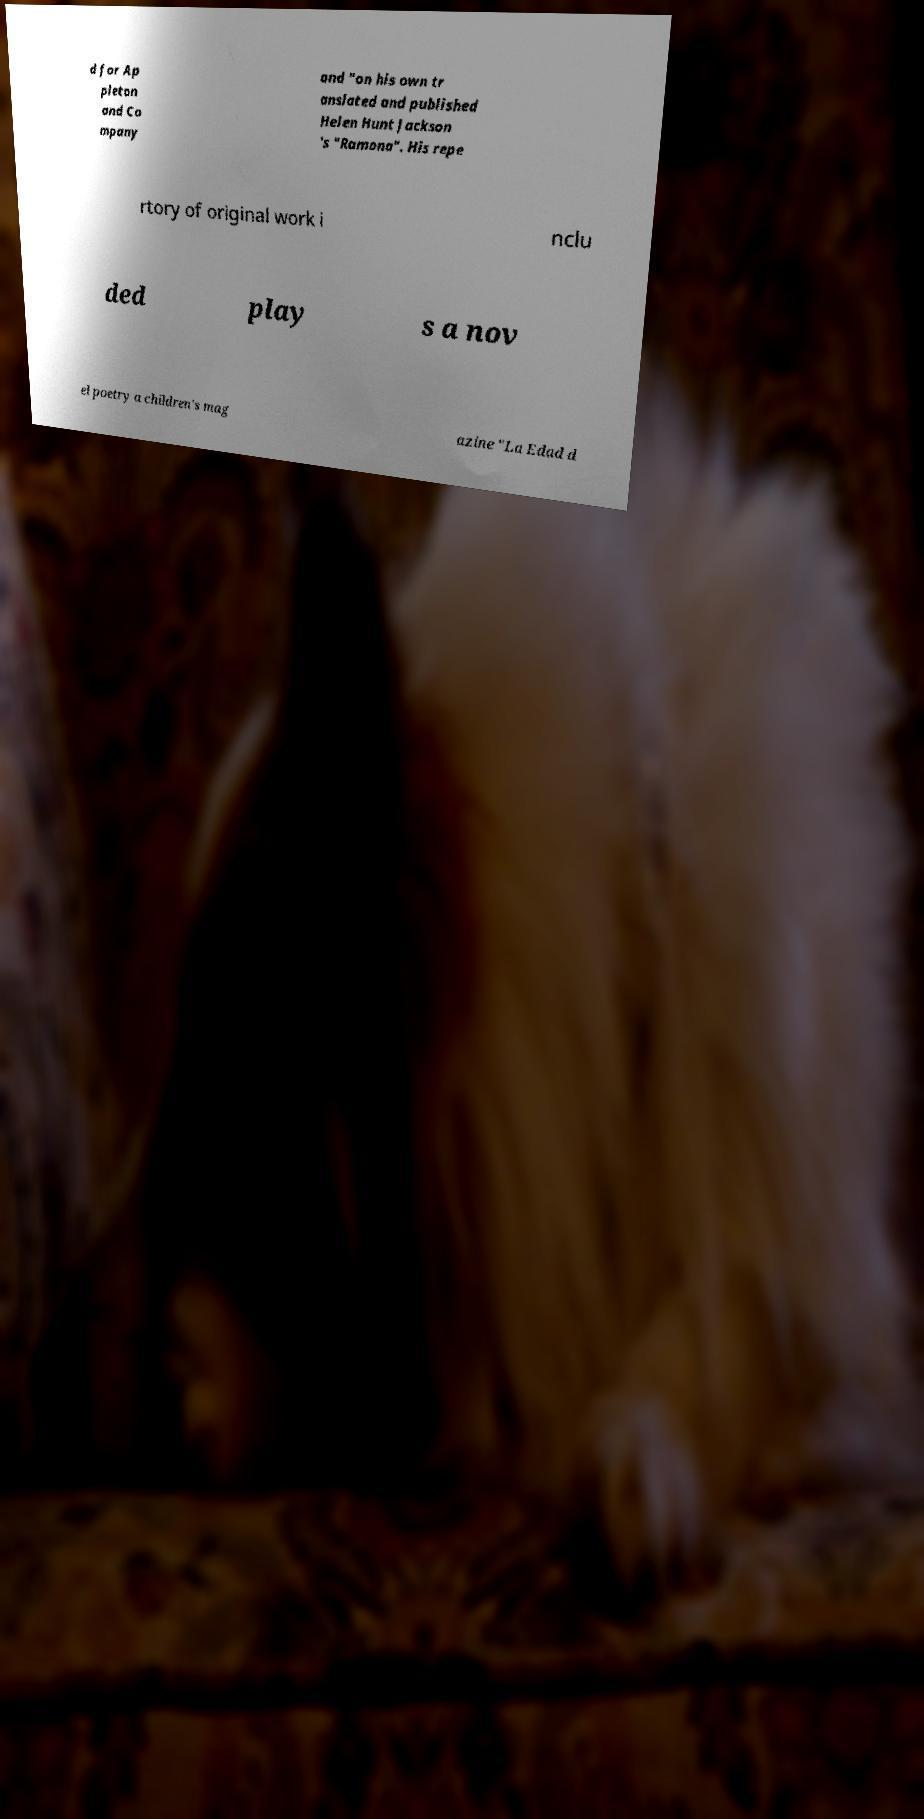What messages or text are displayed in this image? I need them in a readable, typed format. d for Ap pleton and Co mpany and "on his own tr anslated and published Helen Hunt Jackson 's "Ramona". His repe rtory of original work i nclu ded play s a nov el poetry a children's mag azine "La Edad d 